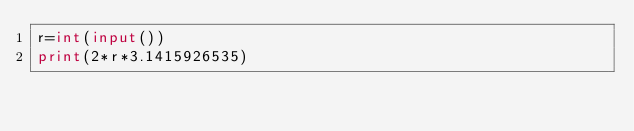<code> <loc_0><loc_0><loc_500><loc_500><_Python_>r=int(input())
print(2*r*3.1415926535)</code> 